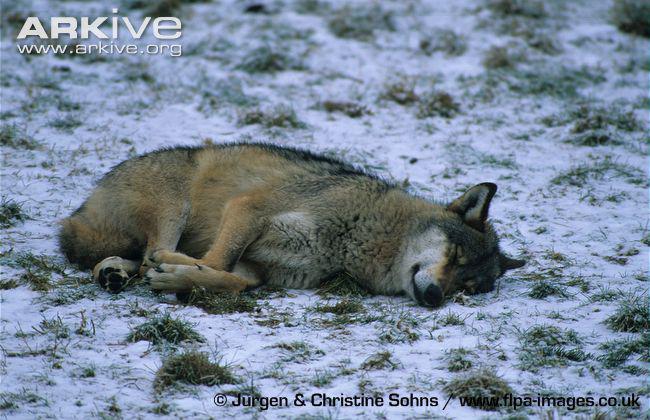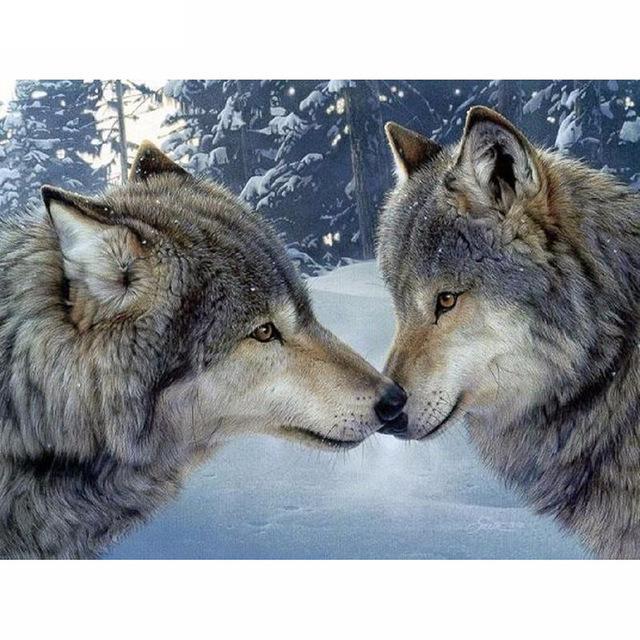The first image is the image on the left, the second image is the image on the right. Given the left and right images, does the statement "One image contains two wolves standing up, and the other contains one wolf sleeping peacefully." hold true? Answer yes or no. Yes. 